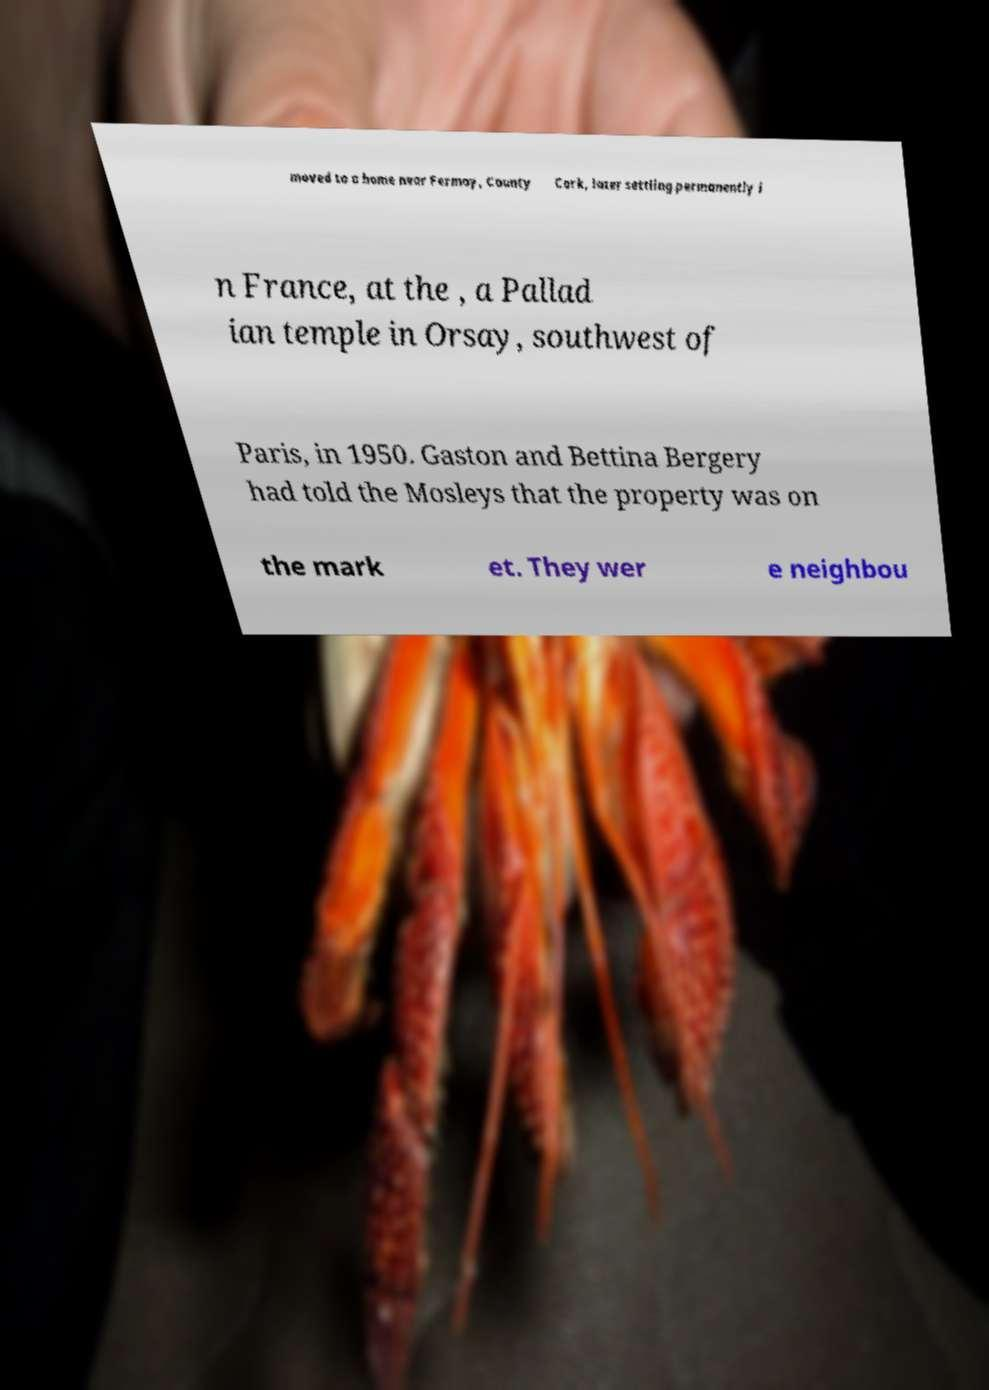What messages or text are displayed in this image? I need them in a readable, typed format. moved to a home near Fermoy, County Cork, later settling permanently i n France, at the , a Pallad ian temple in Orsay, southwest of Paris, in 1950. Gaston and Bettina Bergery had told the Mosleys that the property was on the mark et. They wer e neighbou 